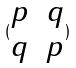Convert formula to latex. <formula><loc_0><loc_0><loc_500><loc_500>( \begin{matrix} p & q \\ q & p \end{matrix} )</formula> 